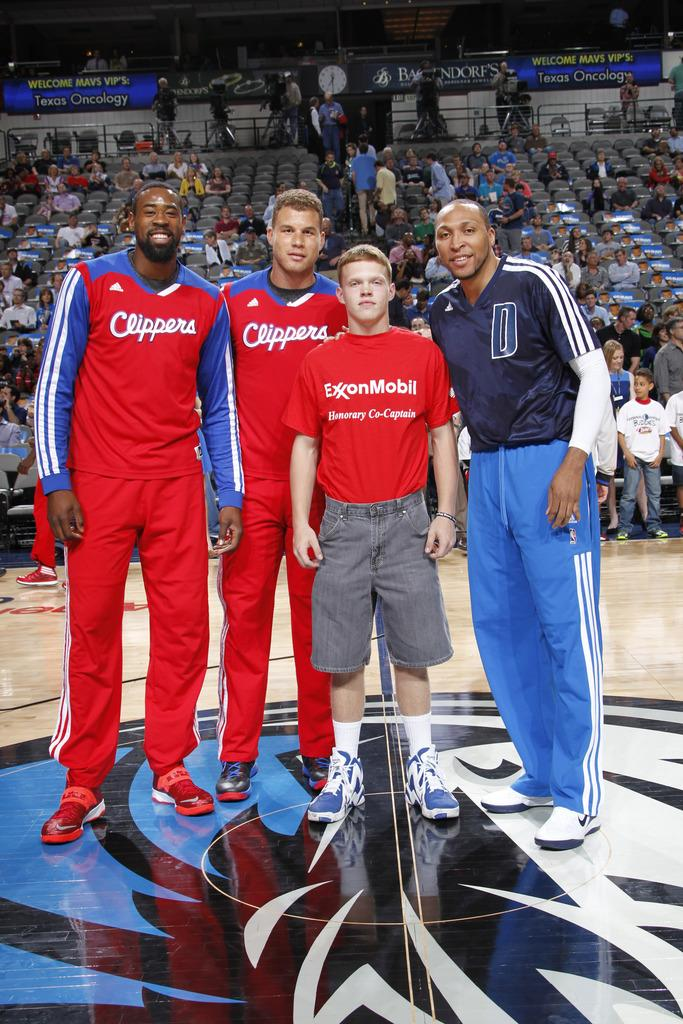<image>
Share a concise interpretation of the image provided. Four men pose for a picture, two with Clippers on their red tops and one with ExonMobil on his. 